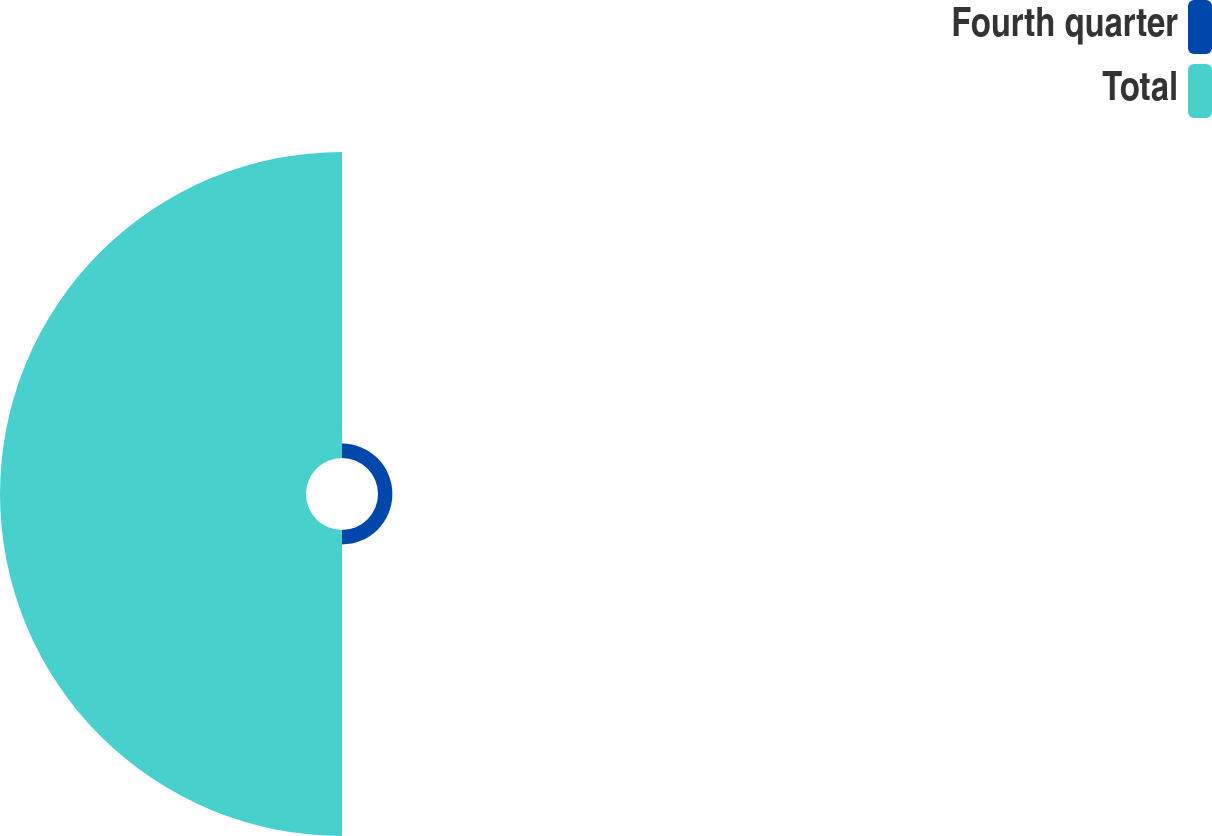Convert chart. <chart><loc_0><loc_0><loc_500><loc_500><pie_chart><fcel>Fourth quarter<fcel>Total<nl><fcel>4.49%<fcel>95.51%<nl></chart> 